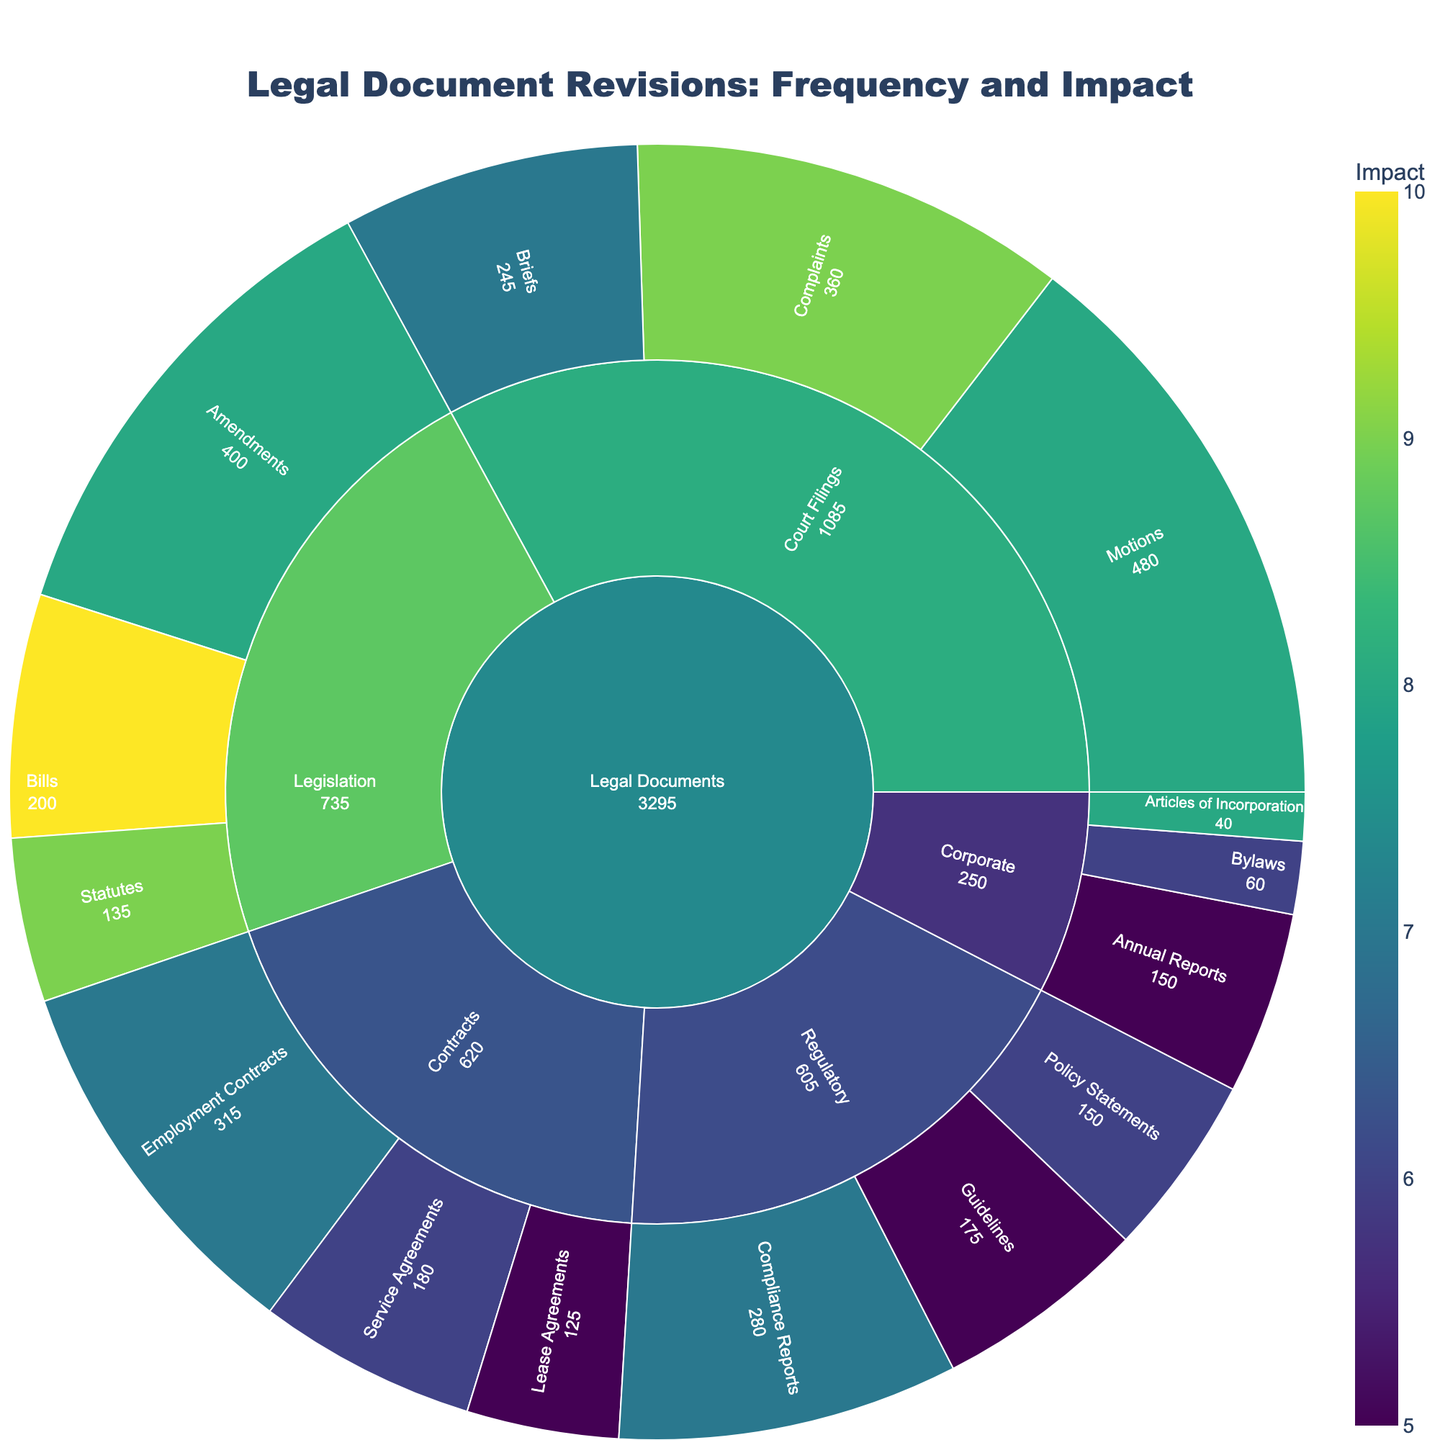What is the title of the figure? The title is located at the top of the figure and provides an overview of the plot. In this case, it reads 'Legal Document Revisions: Frequency and Impact'.
Answer: Legal Document Revisions: Frequency and Impact Which subcategory has the highest frequency within the 'Contracts' category? To find this, look at the 'Contracts' section and compare the frequencies of its subcategories. 'Employment Contracts' has the highest frequency of 45.
Answer: Employment Contracts What is the total impact value for the 'Legislation' category? Add the impact values of the subcategories under 'Legislation': Bills (10) + Amendments (8) + Statutes (9). This results in 10 + 8 + 9 = 27.
Answer: 27 Which category has the highest aggregate value? To determine this, compare the aggregate 'Value' (Frequency * Impact) for each main category. By visual assessment, 'Court Filings' has the highest aggregate value visualized on the plot.
Answer: Court Filings How does the impact of 'Motions' compare to 'Complaints'? Look at the impact values for these subcategories. 'Motions' has an impact of 8, while 'Complaints' has an impact of 9.
Answer: Complaints have a higher impact What is the combined frequency of all subcategories under 'Regulatory'? Sum the frequencies of all subcategories under 'Regulatory': Compliance Reports (40) + Policy Statements (25) + Guidelines (35). This gives 40 + 25 + 35 = 100.
Answer: 100 Which legal document subcategory has the lowest frequency? Identify which subcategory has the smallest visual segment representing frequency. 'Articles of Incorporation' under 'Corporate' has a frequency of 5.
Answer: Articles of Incorporation Among subcategories with an impact value of 6, which has the highest frequency? Locate all subcategories with an impact of 6 and then compare their frequencies. 'Service Agreements' under 'Contracts' has a frequency of 30, which is the highest within this impact value.
Answer: Service Agreements What percentage of the total frequency does the 'Court Filings' category represent? First, sum all the frequencies: 45 + 30 + 25 + 60 + 40 + 35 + 20 + 50 + 15 + 10 + 5 + 30 + 40 + 25 + 35 = 465. Then, calculate the percentage for 'Court Filings': (60 + 40 + 35) = 135. (135 / 465) * 100 ≈ 29.03%.
Answer: 29.03% What color scale is used to represent the impact values? The color scale is indicated in the description of the figure's customization. It uses the 'Viridis' color scale.
Answer: Viridis 